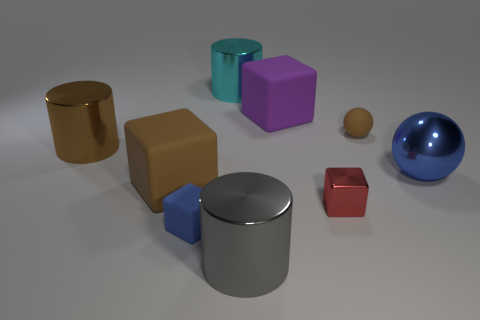Can you describe the arrangement of shapes in relation to the largest cylinder? The largest cylinder, which is silver in color, is centrally located with respect to the other objects. To its left, there is a small red cube and a gold cylinder. Directly in front of it stands a purple cube, and a blue sphere is positioned slightly to its right. Behind the large cylinder, you can see two more objects: a tan rectangle and a smaller cylinder with a blue top. Are any of these objects casting shadows, and if so, which direction does this suggest the light is coming from? Indeed, each object casts a shadow on the ground. The shadows are angled towards the bottom left corner of the image, indicating that the light source is above and to the right, out of the frame. 